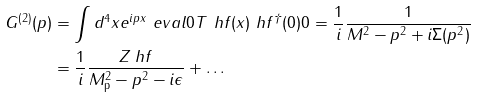Convert formula to latex. <formula><loc_0><loc_0><loc_500><loc_500>G ^ { ( 2 ) } ( p ) & = \int d ^ { 4 } x e ^ { i p x } \ e v a l { 0 } { T \ h f ( x ) \ h f ^ { \dag } ( 0 ) } { 0 } = \frac { 1 } { i } \frac { 1 } { M ^ { 2 } - p ^ { 2 } + i \Sigma ( p ^ { 2 } ) } \\ & = \frac { 1 } { i } \frac { Z _ { \ } h f } { M _ { \text  p}^{2}-p^{2}-i\epsilon} + \dots</formula> 